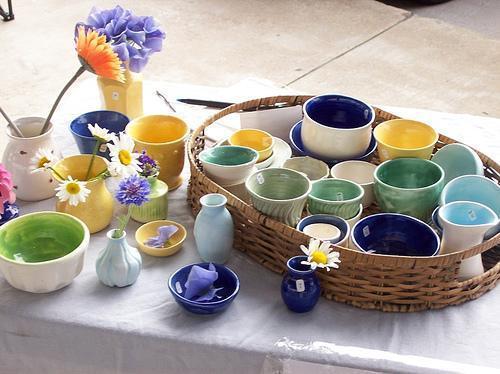How many white flowers are in the photo?
Give a very brief answer. 5. How many bowls are visible?
Give a very brief answer. 8. How many vases are there?
Give a very brief answer. 5. How many cups can you see?
Give a very brief answer. 7. How many people are in the room?
Give a very brief answer. 0. 